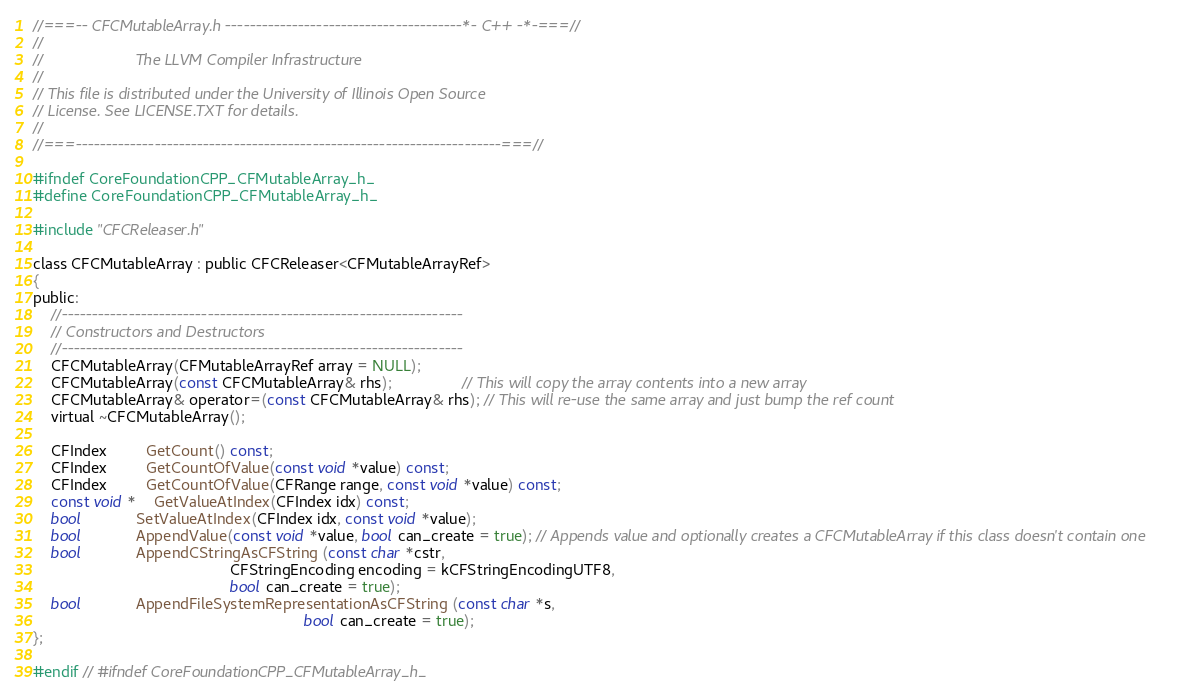<code> <loc_0><loc_0><loc_500><loc_500><_C_>//===-- CFCMutableArray.h ---------------------------------------*- C++ -*-===//
//
//                     The LLVM Compiler Infrastructure
//
// This file is distributed under the University of Illinois Open Source
// License. See LICENSE.TXT for details.
//
//===----------------------------------------------------------------------===//

#ifndef CoreFoundationCPP_CFMutableArray_h_
#define CoreFoundationCPP_CFMutableArray_h_

#include "CFCReleaser.h"

class CFCMutableArray : public CFCReleaser<CFMutableArrayRef>
{
public:
    //------------------------------------------------------------------
    // Constructors and Destructors
    //------------------------------------------------------------------
    CFCMutableArray(CFMutableArrayRef array = NULL);
    CFCMutableArray(const CFCMutableArray& rhs);                // This will copy the array contents into a new array
    CFCMutableArray& operator=(const CFCMutableArray& rhs); // This will re-use the same array and just bump the ref count
    virtual ~CFCMutableArray();

    CFIndex         GetCount() const;
    CFIndex         GetCountOfValue(const void *value) const;
    CFIndex         GetCountOfValue(CFRange range, const void *value) const;
    const void *    GetValueAtIndex(CFIndex idx) const;
    bool            SetValueAtIndex(CFIndex idx, const void *value);
    bool            AppendValue(const void *value, bool can_create = true); // Appends value and optionally creates a CFCMutableArray if this class doesn't contain one
    bool            AppendCStringAsCFString (const char *cstr, 
                                             CFStringEncoding encoding = kCFStringEncodingUTF8, 
                                             bool can_create = true);
    bool            AppendFileSystemRepresentationAsCFString (const char *s, 
                                                              bool can_create = true);
};

#endif // #ifndef CoreFoundationCPP_CFMutableArray_h_
</code> 